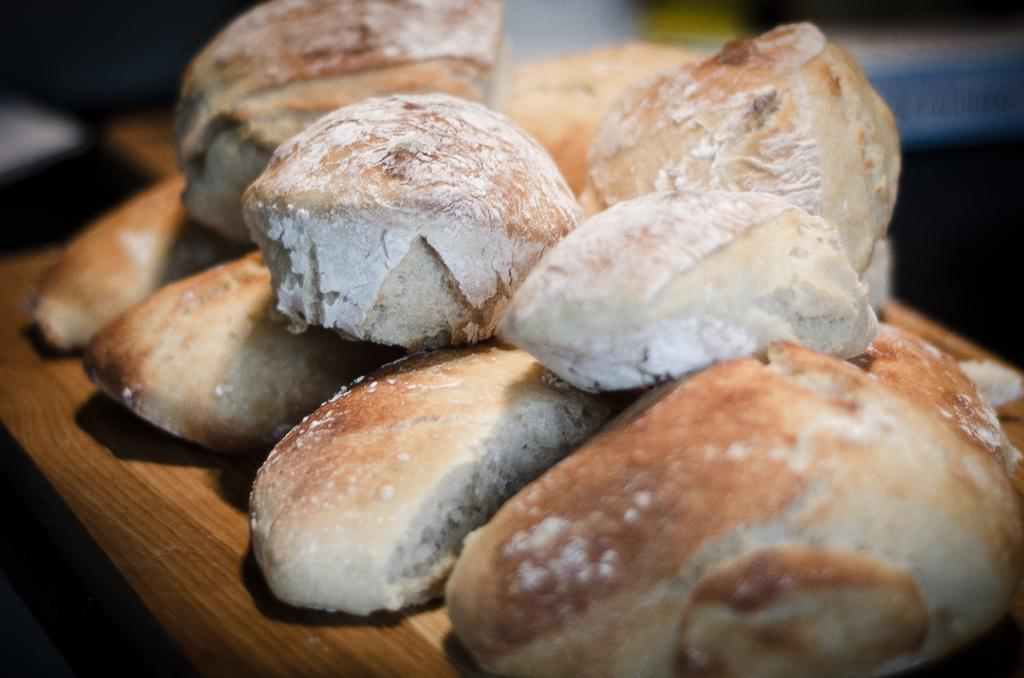What type of food can be seen in the image? There are buns in the image. How do the buns appear? The buns have flour on them. What material is the surface on which the buns are placed? The wooden surface is present in the image. What type of creature is causing destruction to the buns in the image? There is no creature present in the image, and the buns do not appear to be damaged or destroyed. 